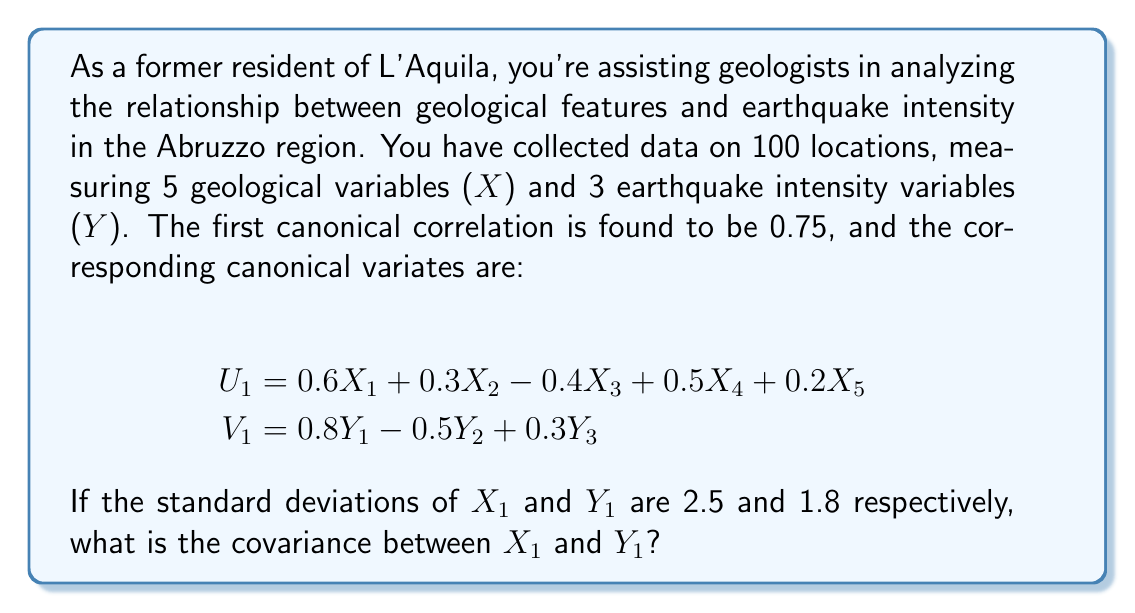Give your solution to this math problem. Let's approach this step-by-step:

1) First, recall that the canonical correlation is the correlation between the canonical variates U and V. So, $\text{Corr}(U_1, V_1) = 0.75$.

2) The relationship between correlation and covariance is:
   $$\text{Corr}(U_1, V_1) = \frac{\text{Cov}(U_1, V_1)}{\sqrt{\text{Var}(U_1)\text{Var}(V_1)}}$$

3) We're interested in $\text{Cov}(X_1, Y_1)$. This can be related to $\text{Cov}(U_1, V_1)$ through the coefficients in the canonical variates:

   $$\text{Cov}(U_1, V_1) = \text{Cov}(0.6X_1 + ... , 0.8Y_1 + ...)$$
   $$= 0.6 \cdot 0.8 \cdot \text{Cov}(X_1, Y_1) + \text{ other terms}$$

4) Assuming the variables are standardized (which is common in CCA), the other terms will be zero, so:
   $$\text{Cov}(U_1, V_1) = 0.6 \cdot 0.8 \cdot \text{Cov}(X_1, Y_1) = 0.48 \cdot \text{Cov}(X_1, Y_1)$$

5) From step 2, we can write:
   $$0.75 = \frac{0.48 \cdot \text{Cov}(X_1, Y_1)}{\sqrt{\text{Var}(U_1)\text{Var}(V_1)}}$$

6) Assuming unit variance for standardized U and V:
   $$0.75 = 0.48 \cdot \text{Cov}(X_1, Y_1)$$

7) Solving for $\text{Cov}(X_1, Y_1)$:
   $$\text{Cov}(X_1, Y_1) = \frac{0.75}{0.48} = 1.5625$$

8) However, we're given that $X_1$ and $Y_1$ are not standardized. Their standard deviations are 2.5 and 1.8 respectively. We need to scale our result:

   $$\text{Cov}(X_1, Y_1) = 1.5625 \cdot 2.5 \cdot 1.8 = 7.03125$$

Therefore, the covariance between $X_1$ and $Y_1$ is approximately 7.03.
Answer: 7.03 